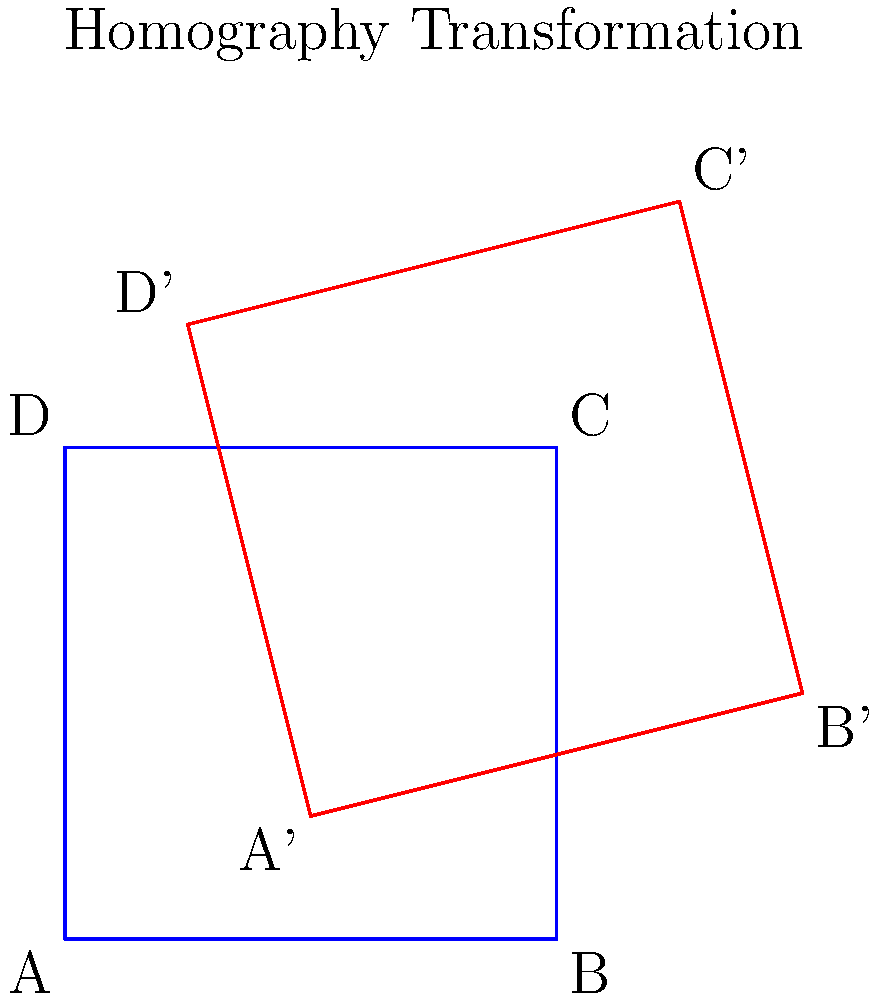Given two images of a planar surface as shown in the figure, where the blue rectangle represents the original image and the red quadrilateral represents the transformed image, how many point correspondences are minimally required to estimate the homography matrix between these two images? To estimate the homography matrix between two images of a planar surface, we need to follow these steps:

1. Understand the homography matrix:
   The homography matrix $H$ is a 3x3 matrix that relates the coordinates of points in one image to the corresponding points in another image of the same planar surface.

2. Consider the degrees of freedom:
   A 3x3 homography matrix has 9 elements, but it is defined up to a scale factor. This means it effectively has 8 degrees of freedom.

3. Determine the number of equations per point correspondence:
   Each point correspondence provides two equations: one for the x-coordinate and one for the y-coordinate.

4. Calculate the minimum number of point correspondences:
   To solve for 8 unknowns (degrees of freedom), we need at least 8 equations.
   Since each point correspondence provides 2 equations, we need:
   $\frac{8 \text{ equations}}{2 \text{ equations per point}} = 4 \text{ points}$

5. Verify the result:
   With 4 point correspondences, we have 8 equations to solve for the 8 unknowns in the homography matrix.

Therefore, a minimum of 4 point correspondences are required to estimate the homography matrix between two images of the same planar surface.
Answer: 4 point correspondences 